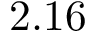<formula> <loc_0><loc_0><loc_500><loc_500>2 . 1 6</formula> 